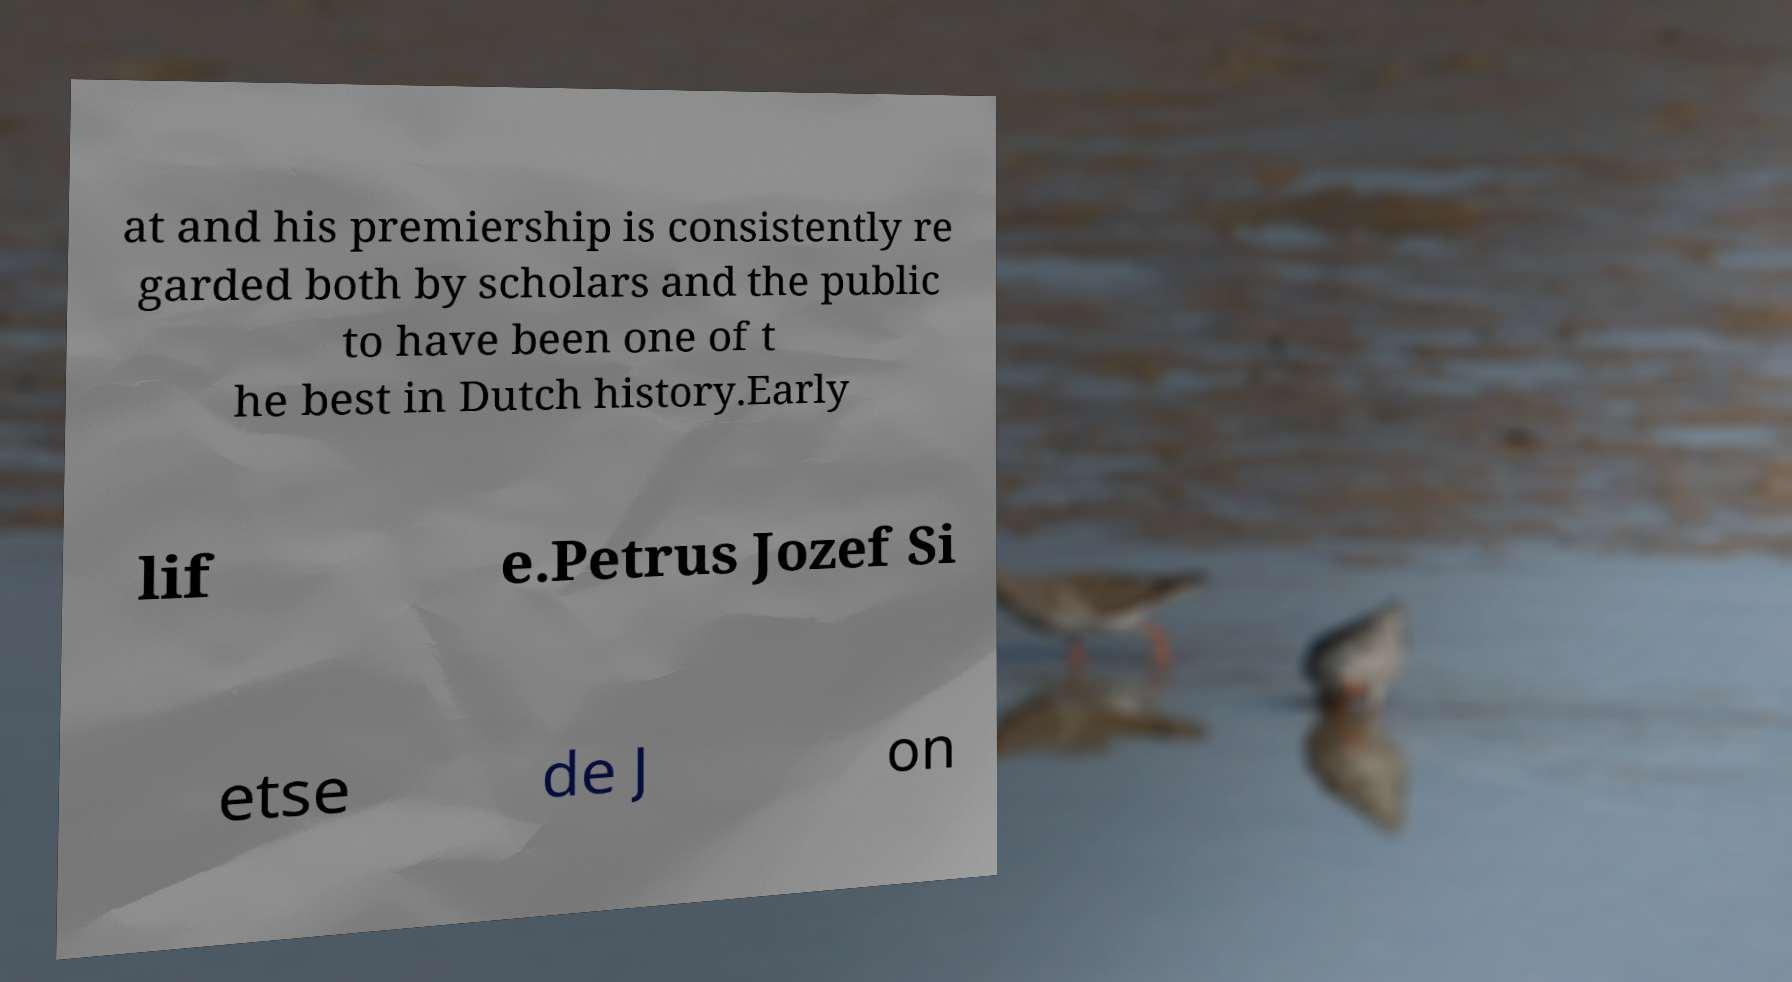Can you accurately transcribe the text from the provided image for me? at and his premiership is consistently re garded both by scholars and the public to have been one of t he best in Dutch history.Early lif e.Petrus Jozef Si etse de J on 